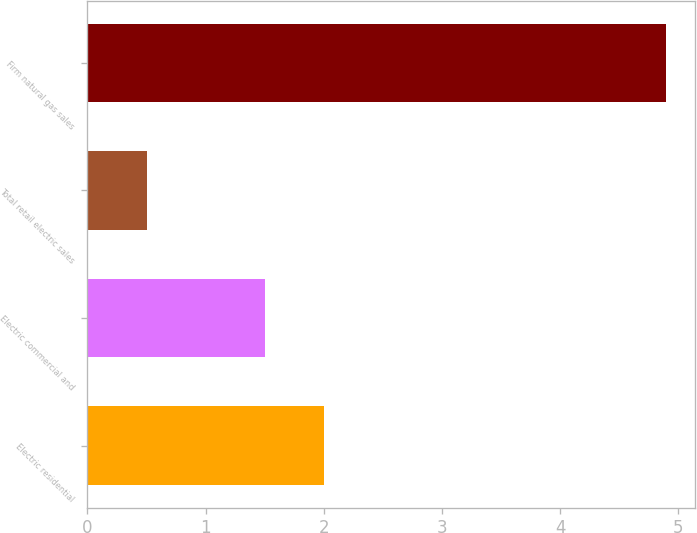Convert chart. <chart><loc_0><loc_0><loc_500><loc_500><bar_chart><fcel>Electric residential<fcel>Electric commercial and<fcel>Total retail electric sales<fcel>Firm natural gas sales<nl><fcel>2<fcel>1.5<fcel>0.5<fcel>4.9<nl></chart> 